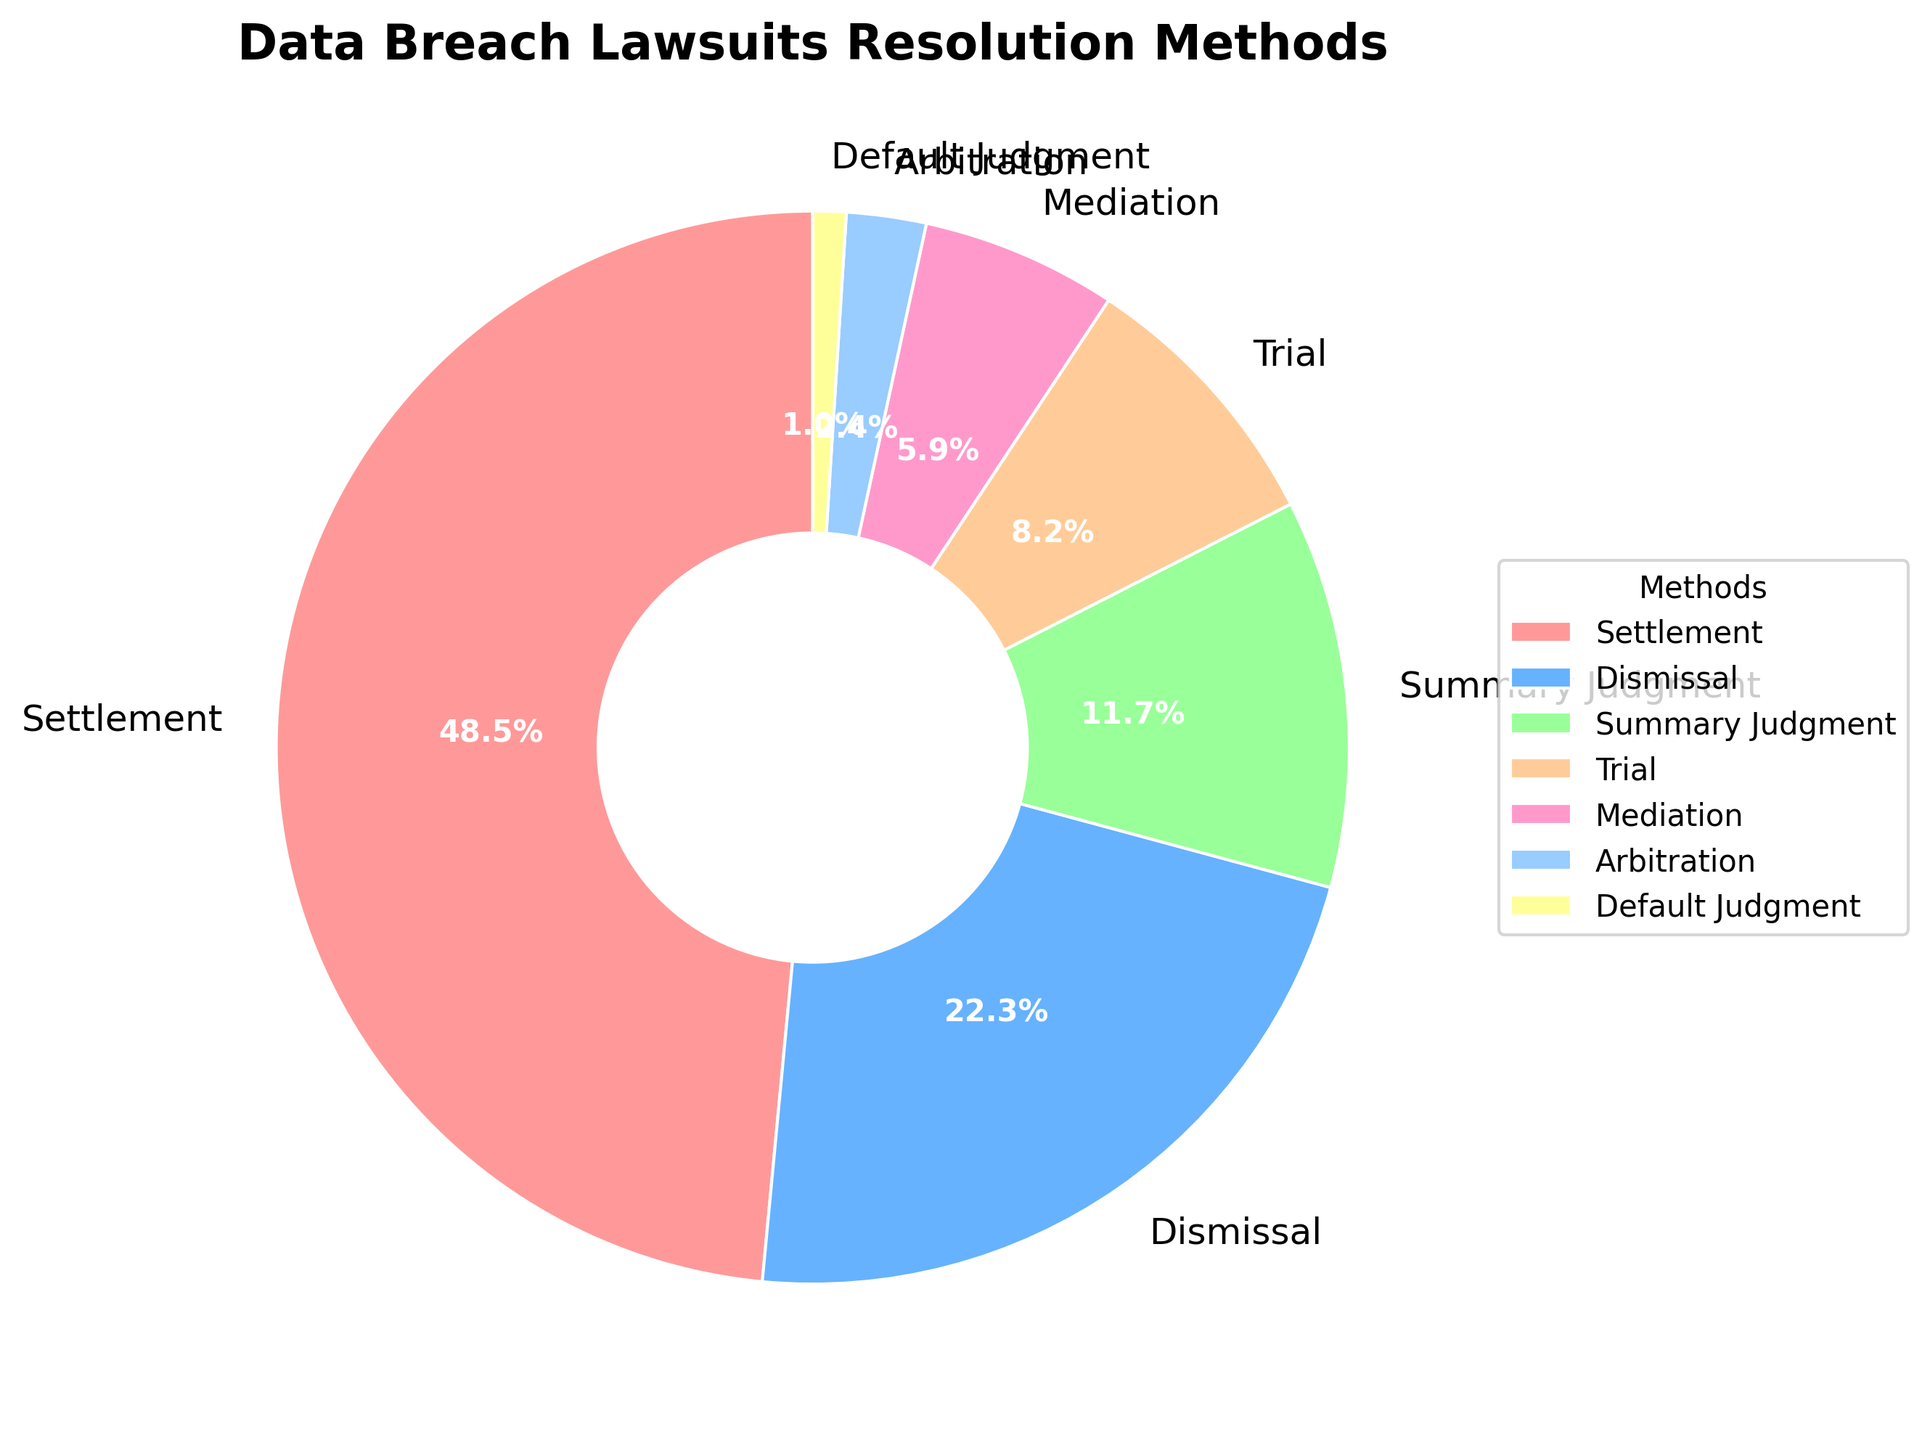What method resolves the highest percentage of data breach lawsuits? The segment labeled "Settlement" shows 48.5%, which is the highest percentage compared to other methods like Dismissal (22.3%), Summary Judgment (11.7%), etc.
Answer: Settlement Which method has the lowest percentage? The pie chart segment labeled "Default Judgment" indicates 1.0%, which is the lowest percentage among all methods listed.
Answer: Default Judgment How much more common is Settlement compared to Dismissal? The Settlement segment shows 48.5% and the Dismissal segment shows 22.3%. The difference is calculated as 48.5% - 22.3% = 26.2%.
Answer: 26.2% Which method, shown in yellow, resolves data breach lawsuits? The pie chart segment representing Default Judgment is shown in yellow, and it resolves 1.0% of data breach lawsuits.
Answer: Default Judgment What is the total percentage resolved through either Mediation or Arbitration? The Mediation segment shows 5.9% and the Arbitration segment shows 2.4%. Adding these, 5.9% + 2.4% = 8.3%.
Answer: 8.3% How much less common is Trial compared to Summary Judgment? The Trial segment shows 8.2%, and the Summary Judgment segment shows 11.7%. The difference is 11.7% - 8.2% = 3.5%.
Answer: 3.5% Which methods combined account for less than 10% of resolutions? Adding percentages for methods Arbitration (2.4%) and Default Judgment (1.0%), we get 2.4% + 1.0% = 3.4%, which is less than 10%.
Answer: Arbitration, Default Judgment Are more lawsuits resolved through Trial or through Summary Judgment? The Summary Judgment segment shows 11.7% while the Trial segment shows 8.2%. Therefore, more lawsuits are resolved through Summary Judgment.
Answer: Summary Judgment 